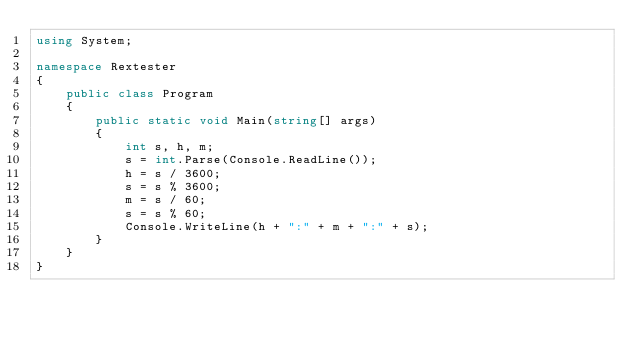<code> <loc_0><loc_0><loc_500><loc_500><_C#_>using System;

namespace Rextester
{
    public class Program
    {
        public static void Main(string[] args)
        {
            int s, h, m;
            s = int.Parse(Console.ReadLine());
            h = s / 3600;
            s = s % 3600;
            m = s / 60;
            s = s % 60;
            Console.WriteLine(h + ":" + m + ":" + s);
        }
    }
}
</code> 